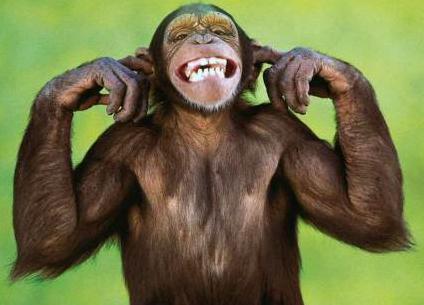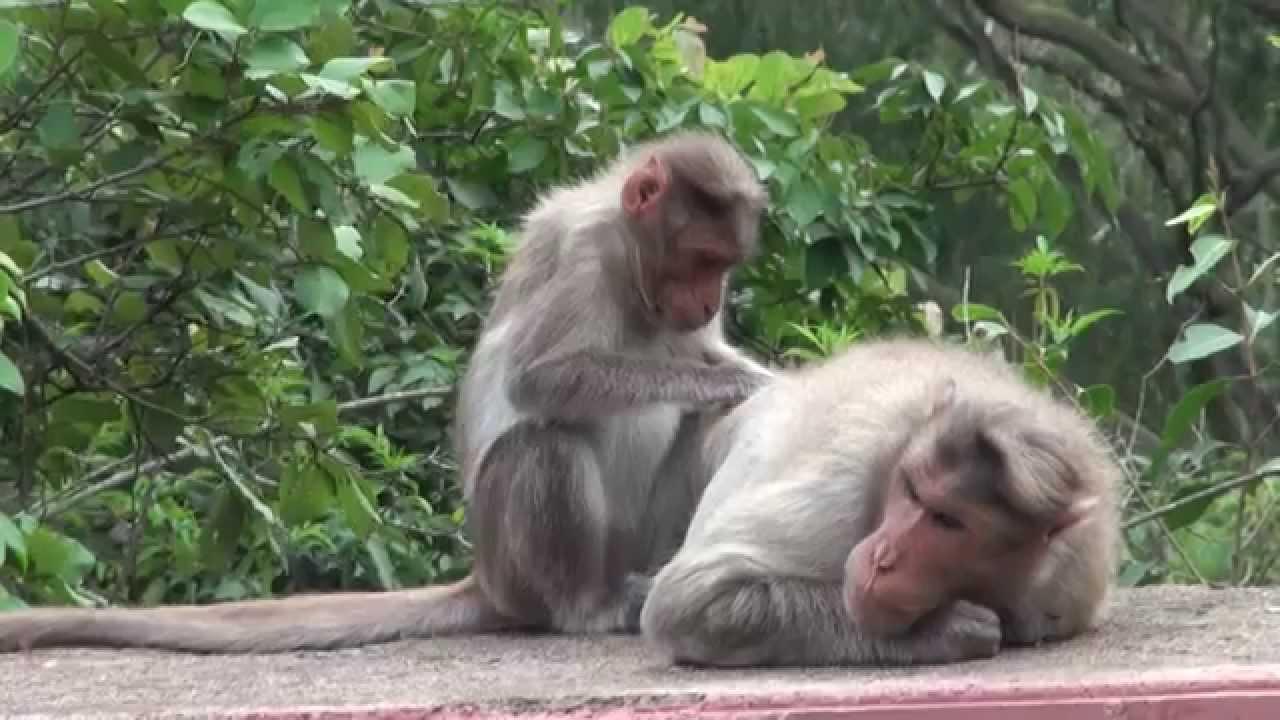The first image is the image on the left, the second image is the image on the right. For the images shown, is this caption "There are four primates." true? Answer yes or no. No. The first image is the image on the left, the second image is the image on the right. For the images shown, is this caption "At least one ape is showing its teeth." true? Answer yes or no. Yes. 